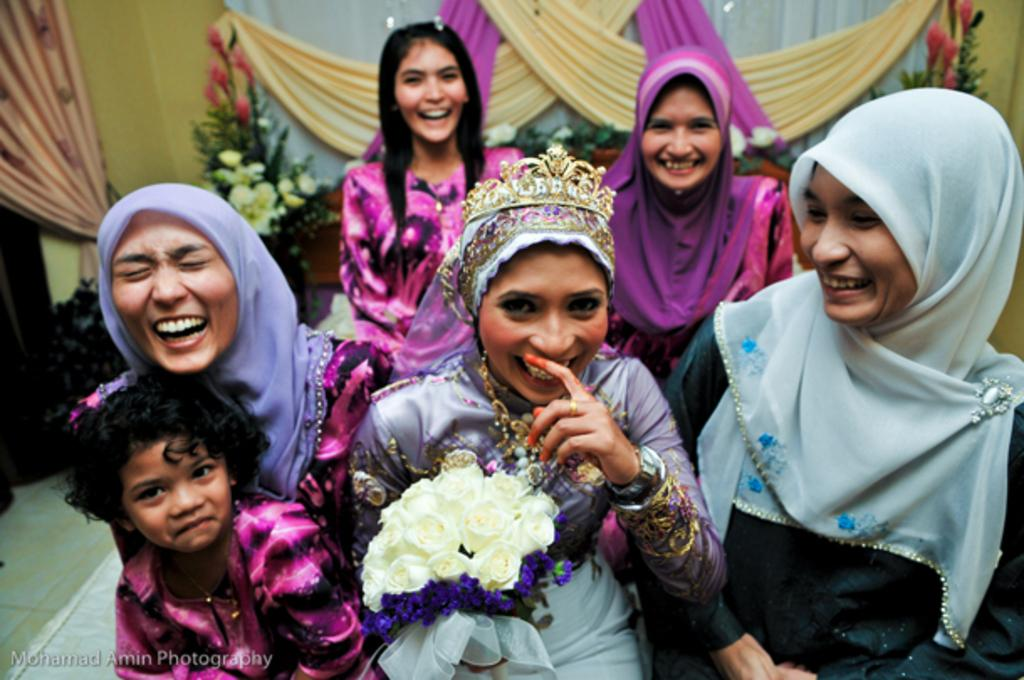What is the main subject of the image? The main subject of the image is a group of people. What can be observed about the people in the image? The people are wearing clothes. Can you describe the person in the middle of the image? The person in the middle of the image is wearing a crown. Where are the clothes located in the image? There are clothes visible at the top of the image. What type of truck can be seen driving through the image? There is no truck present in the image; it features a group of people, some of whom are wearing clothes and one of whom is wearing a crown. How many mittens are visible in the image? There are no mittens present in the image. 